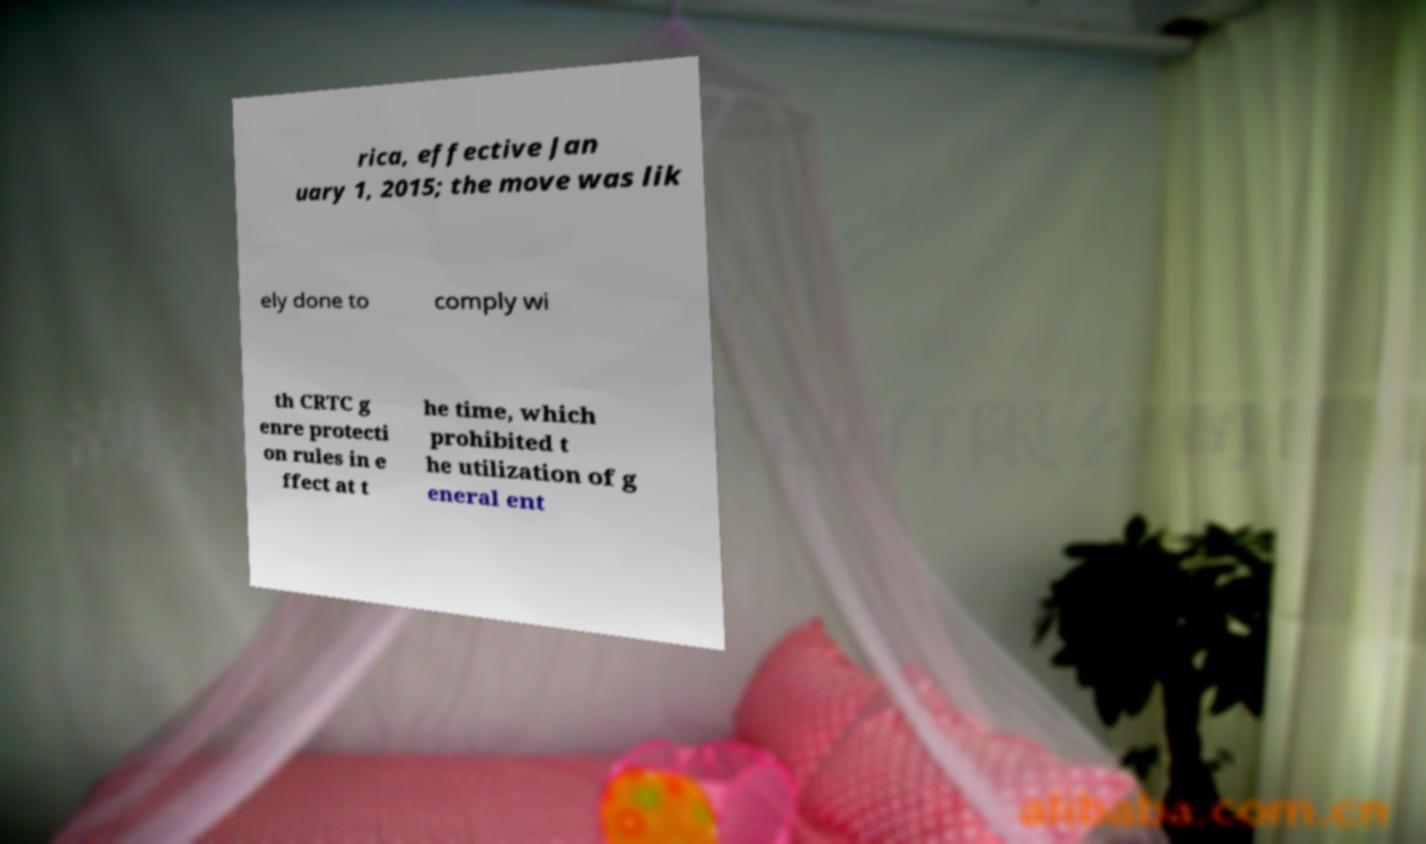Can you accurately transcribe the text from the provided image for me? rica, effective Jan uary 1, 2015; the move was lik ely done to comply wi th CRTC g enre protecti on rules in e ffect at t he time, which prohibited t he utilization of g eneral ent 